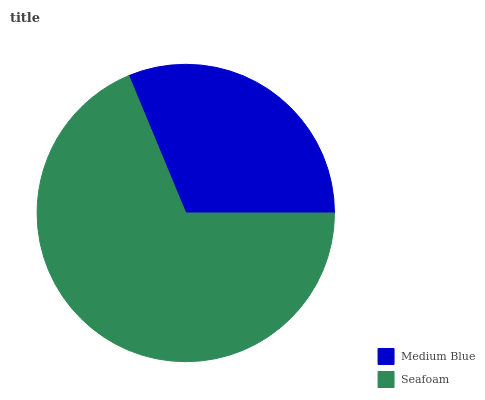Is Medium Blue the minimum?
Answer yes or no. Yes. Is Seafoam the maximum?
Answer yes or no. Yes. Is Seafoam the minimum?
Answer yes or no. No. Is Seafoam greater than Medium Blue?
Answer yes or no. Yes. Is Medium Blue less than Seafoam?
Answer yes or no. Yes. Is Medium Blue greater than Seafoam?
Answer yes or no. No. Is Seafoam less than Medium Blue?
Answer yes or no. No. Is Seafoam the high median?
Answer yes or no. Yes. Is Medium Blue the low median?
Answer yes or no. Yes. Is Medium Blue the high median?
Answer yes or no. No. Is Seafoam the low median?
Answer yes or no. No. 